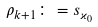Convert formula to latex. <formula><loc_0><loc_0><loc_500><loc_500>\rho _ { k + 1 } \colon = s _ { \varkappa _ { 0 } }</formula> 